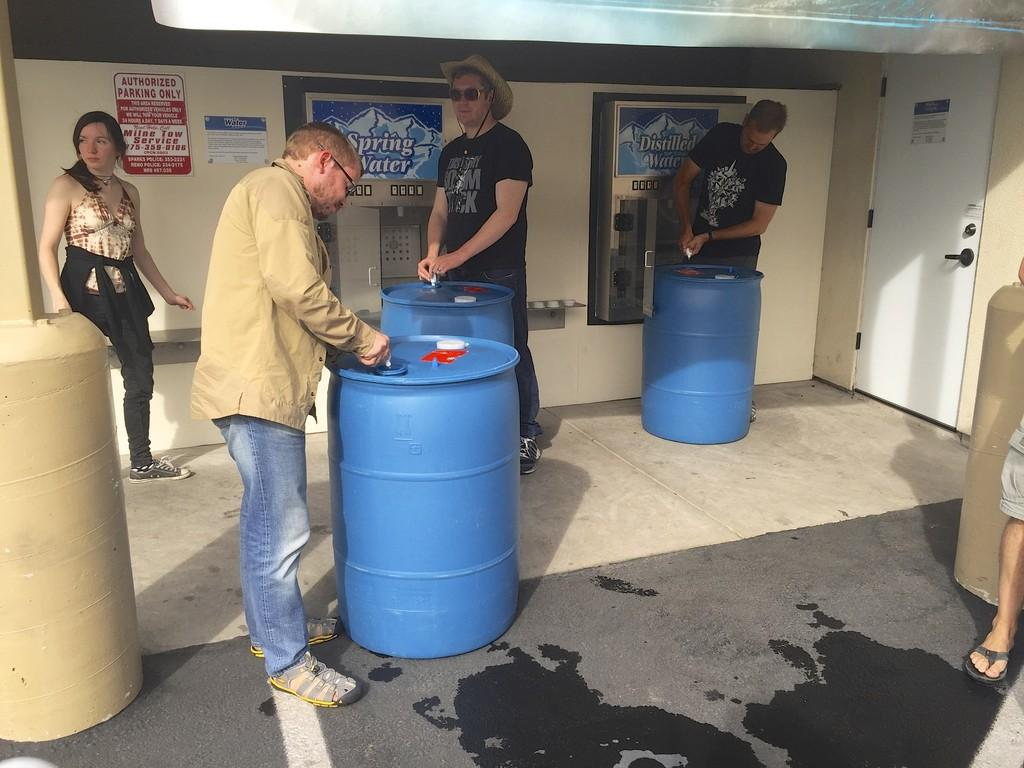<image>
Present a compact description of the photo's key features. Some men are working on blue barrels in front of a sign that says spring water. 